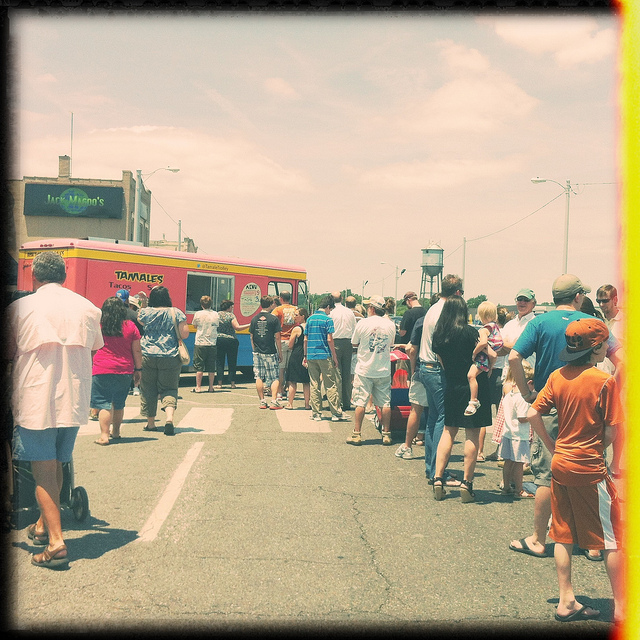Extract all visible text content from this image. JACK MIGOO'S TAMALES Tacos 